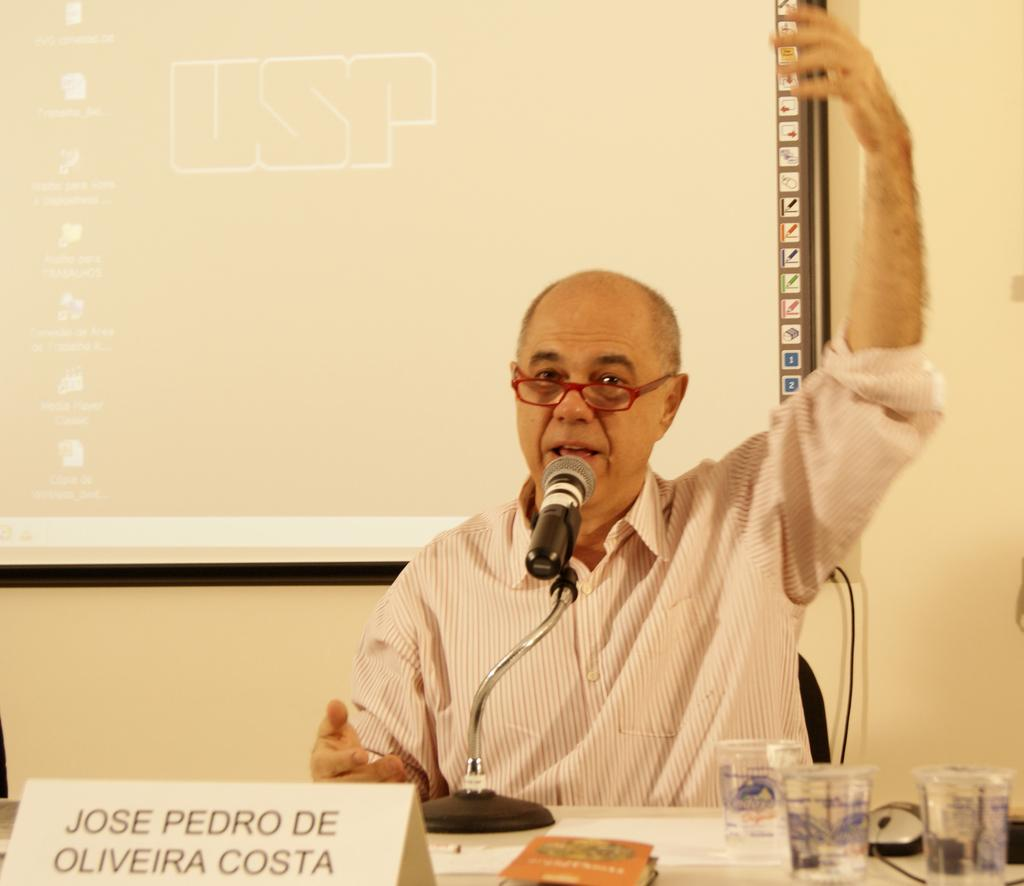What is the person in the image doing? The person is sitting at the table in the image. What object is on the table that is typically used for amplifying sound? There is a microphone on the table. What object on the table might be used for displaying a name or title? There is a name board on the table. What objects on the table might be used for drinking? There are glasses on the table. What object on the table might be used for reading? There is a book on the table. What can be seen in the background of the image? There is a wall and a screen in the background of the image. What disease is the person in the image suffering from? There is no indication in the image that the person in the image is suffering from any disease. What letter is the person in the image holding? There is no letter present in the image. 